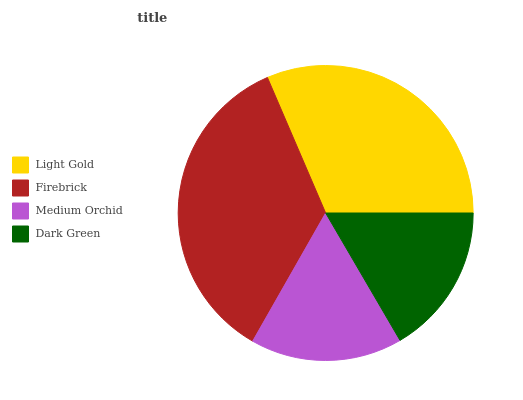Is Dark Green the minimum?
Answer yes or no. Yes. Is Firebrick the maximum?
Answer yes or no. Yes. Is Medium Orchid the minimum?
Answer yes or no. No. Is Medium Orchid the maximum?
Answer yes or no. No. Is Firebrick greater than Medium Orchid?
Answer yes or no. Yes. Is Medium Orchid less than Firebrick?
Answer yes or no. Yes. Is Medium Orchid greater than Firebrick?
Answer yes or no. No. Is Firebrick less than Medium Orchid?
Answer yes or no. No. Is Light Gold the high median?
Answer yes or no. Yes. Is Medium Orchid the low median?
Answer yes or no. Yes. Is Firebrick the high median?
Answer yes or no. No. Is Light Gold the low median?
Answer yes or no. No. 